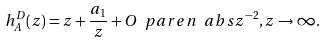<formula> <loc_0><loc_0><loc_500><loc_500>h _ { A } ^ { D } ( z ) = z + \frac { a _ { 1 } } { z } + O \ p a r e n { \ a b s { z } ^ { - 2 } } , z \rightarrow \infty .</formula> 